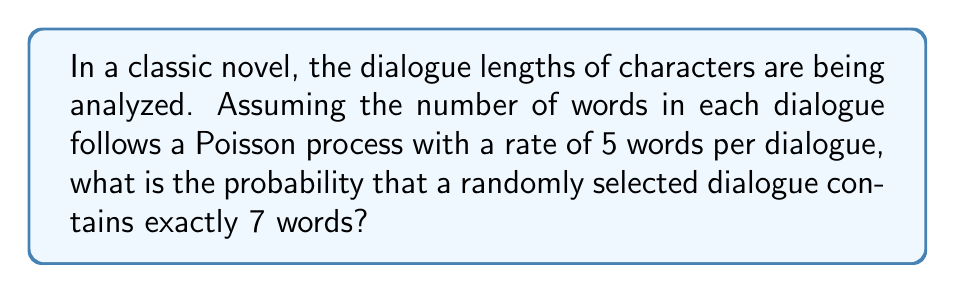Solve this math problem. To solve this problem, we'll use the Poisson distribution formula. For a Poisson process with rate $\lambda$, the probability of exactly $k$ events occurring is given by:

$$P(X = k) = \frac{e^{-\lambda} \lambda^k}{k!}$$

Where:
$\lambda$ = average rate of occurrence
$k$ = number of occurrences we're interested in
$e$ = Euler's number (approximately 2.71828)

Given:
$\lambda = 5$ (words per dialogue)
$k = 7$ (words in the selected dialogue)

Let's substitute these values into the formula:

$$P(X = 7) = \frac{e^{-5} 5^7}{7!}$$

Now, let's calculate step by step:

1) $e^{-5} \approx 0.00674$

2) $5^7 = 78125$

3) $7! = 7 \times 6 \times 5 \times 4 \times 3 \times 2 \times 1 = 5040$

4) Substituting these values:

   $$P(X = 7) = \frac{0.00674 \times 78125}{5040} \approx 0.1049$$

5) Converting to a percentage: $0.1049 \times 100\% \approx 10.49\%$

Therefore, the probability that a randomly selected dialogue contains exactly 7 words is approximately 10.49%.
Answer: $10.49\%$ 